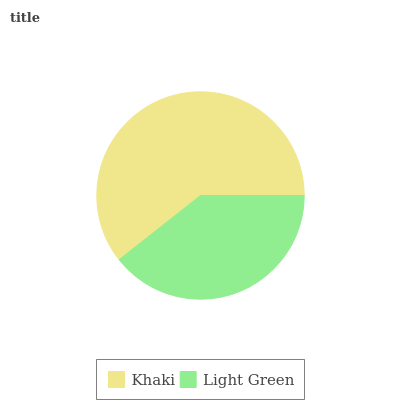Is Light Green the minimum?
Answer yes or no. Yes. Is Khaki the maximum?
Answer yes or no. Yes. Is Light Green the maximum?
Answer yes or no. No. Is Khaki greater than Light Green?
Answer yes or no. Yes. Is Light Green less than Khaki?
Answer yes or no. Yes. Is Light Green greater than Khaki?
Answer yes or no. No. Is Khaki less than Light Green?
Answer yes or no. No. Is Khaki the high median?
Answer yes or no. Yes. Is Light Green the low median?
Answer yes or no. Yes. Is Light Green the high median?
Answer yes or no. No. Is Khaki the low median?
Answer yes or no. No. 